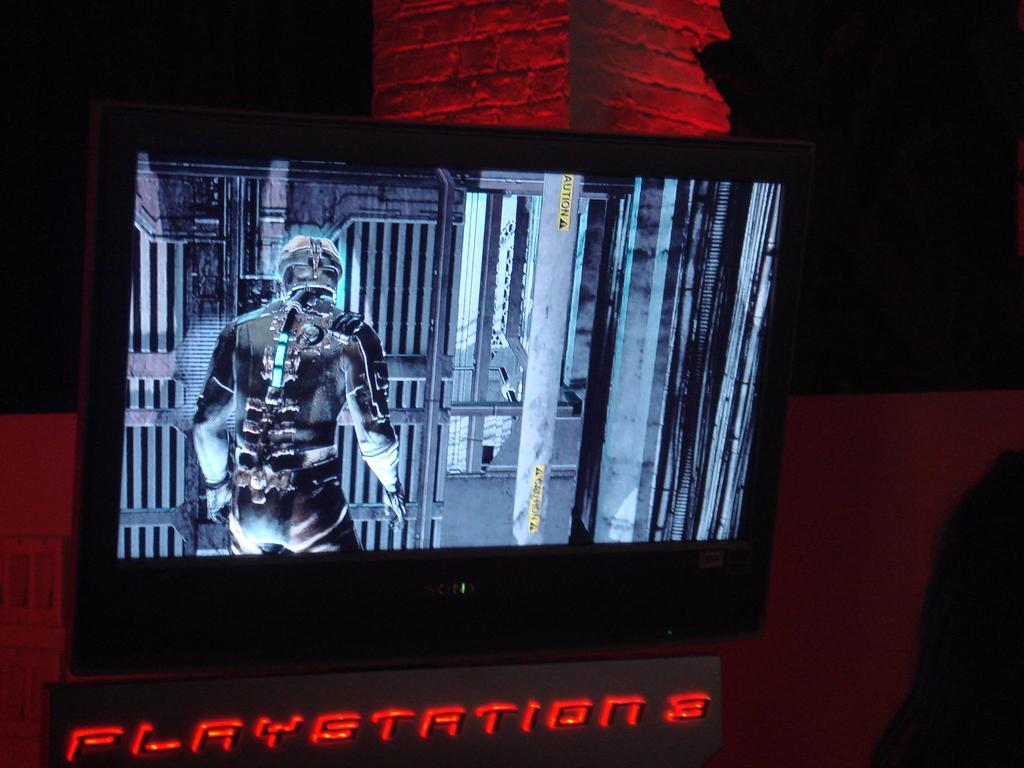<image>
Relay a brief, clear account of the picture shown. A video game is being played on a Playstation 3. 